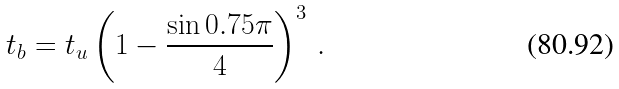<formula> <loc_0><loc_0><loc_500><loc_500>t _ { b } = t _ { u } \left ( 1 - \frac { \sin 0 . 7 5 \pi } { 4 } \right ) ^ { 3 } \, .</formula> 